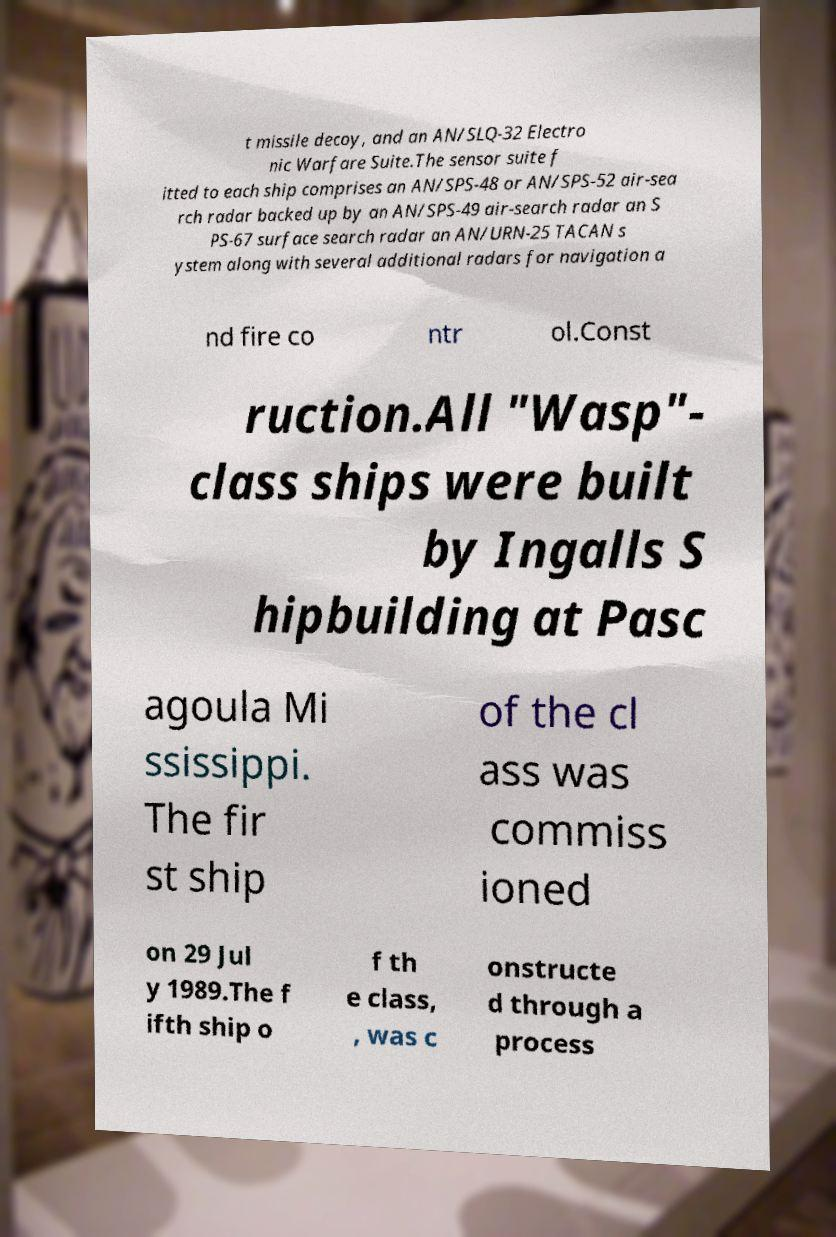There's text embedded in this image that I need extracted. Can you transcribe it verbatim? t missile decoy, and an AN/SLQ-32 Electro nic Warfare Suite.The sensor suite f itted to each ship comprises an AN/SPS-48 or AN/SPS-52 air-sea rch radar backed up by an AN/SPS-49 air-search radar an S PS-67 surface search radar an AN/URN-25 TACAN s ystem along with several additional radars for navigation a nd fire co ntr ol.Const ruction.All "Wasp"- class ships were built by Ingalls S hipbuilding at Pasc agoula Mi ssissippi. The fir st ship of the cl ass was commiss ioned on 29 Jul y 1989.The f ifth ship o f th e class, , was c onstructe d through a process 